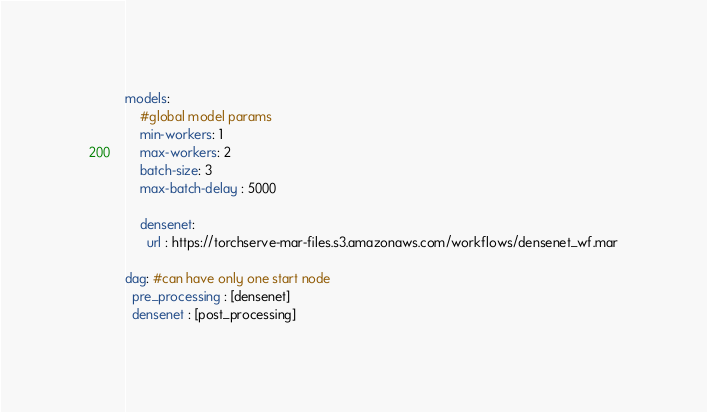Convert code to text. <code><loc_0><loc_0><loc_500><loc_500><_YAML_>models:
    #global model params
    min-workers: 1
    max-workers: 2
    batch-size: 3
    max-batch-delay : 5000

    densenet:
      url : https://torchserve-mar-files.s3.amazonaws.com/workflows/densenet_wf.mar
 
dag: #can have only one start node
  pre_processing : [densenet]
  densenet : [post_processing]</code> 